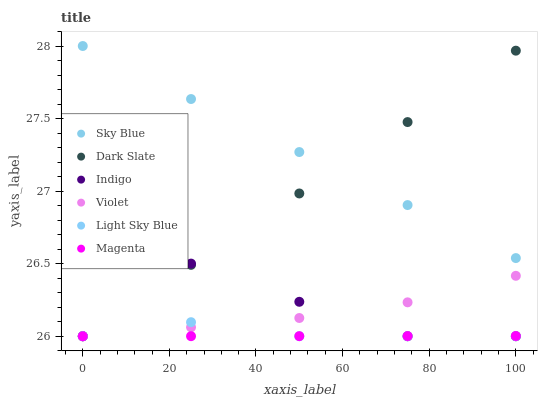Does Magenta have the minimum area under the curve?
Answer yes or no. Yes. Does Sky Blue have the maximum area under the curve?
Answer yes or no. Yes. Does Dark Slate have the minimum area under the curve?
Answer yes or no. No. Does Dark Slate have the maximum area under the curve?
Answer yes or no. No. Is Dark Slate the smoothest?
Answer yes or no. Yes. Is Indigo the roughest?
Answer yes or no. Yes. Is Light Sky Blue the smoothest?
Answer yes or no. No. Is Light Sky Blue the roughest?
Answer yes or no. No. Does Indigo have the lowest value?
Answer yes or no. Yes. Does Sky Blue have the lowest value?
Answer yes or no. No. Does Sky Blue have the highest value?
Answer yes or no. Yes. Does Dark Slate have the highest value?
Answer yes or no. No. Is Indigo less than Sky Blue?
Answer yes or no. Yes. Is Sky Blue greater than Magenta?
Answer yes or no. Yes. Does Violet intersect Indigo?
Answer yes or no. Yes. Is Violet less than Indigo?
Answer yes or no. No. Is Violet greater than Indigo?
Answer yes or no. No. Does Indigo intersect Sky Blue?
Answer yes or no. No. 